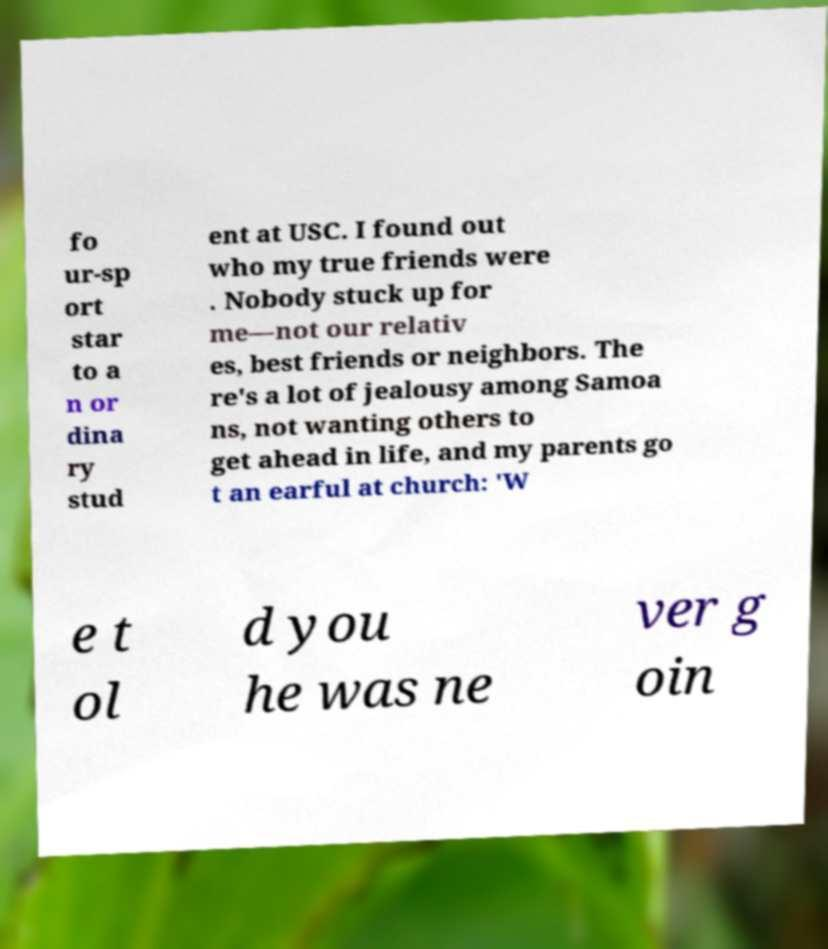Could you assist in decoding the text presented in this image and type it out clearly? fo ur-sp ort star to a n or dina ry stud ent at USC. I found out who my true friends were . Nobody stuck up for me—not our relativ es, best friends or neighbors. The re's a lot of jealousy among Samoa ns, not wanting others to get ahead in life, and my parents go t an earful at church: 'W e t ol d you he was ne ver g oin 